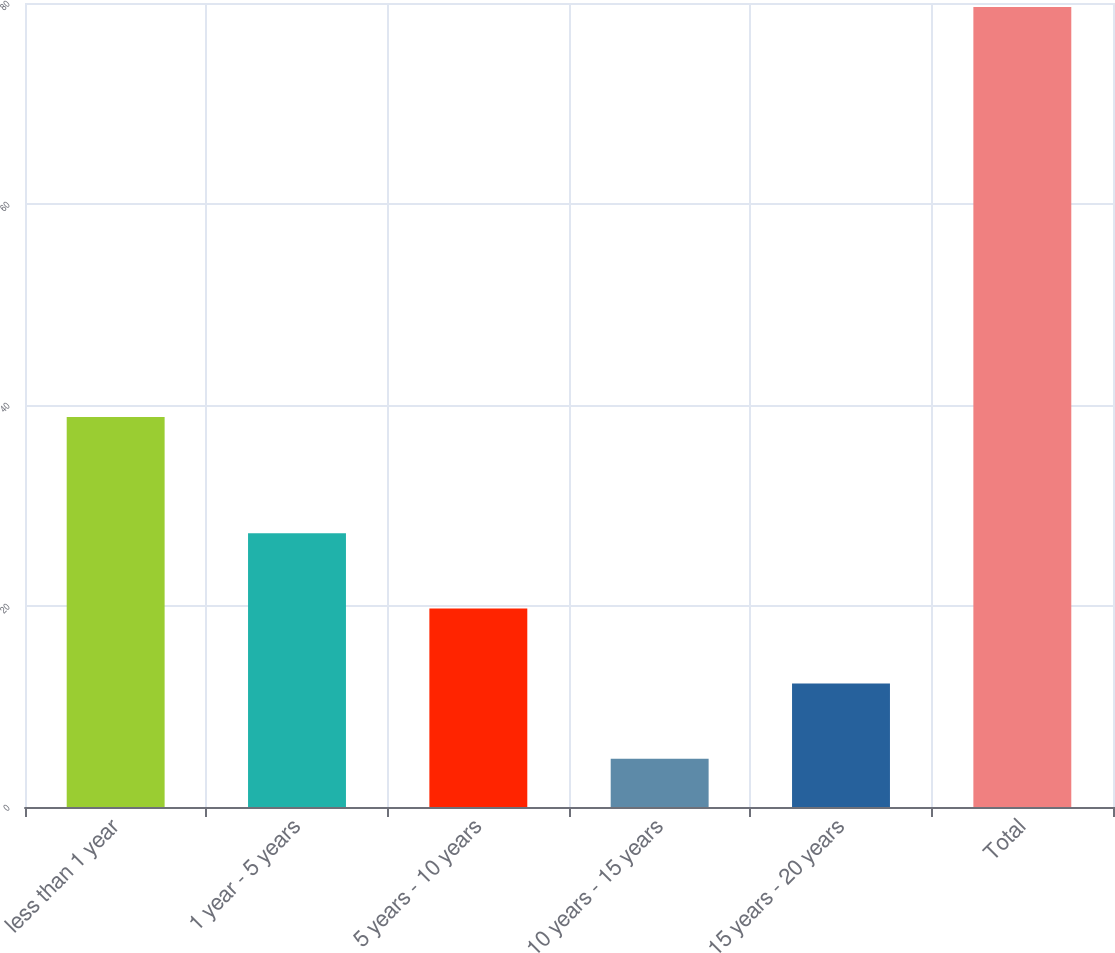<chart> <loc_0><loc_0><loc_500><loc_500><bar_chart><fcel>less than 1 year<fcel>1 year - 5 years<fcel>5 years - 10 years<fcel>10 years - 15 years<fcel>15 years - 20 years<fcel>Total<nl><fcel>38.8<fcel>27.24<fcel>19.76<fcel>4.8<fcel>12.28<fcel>79.6<nl></chart> 